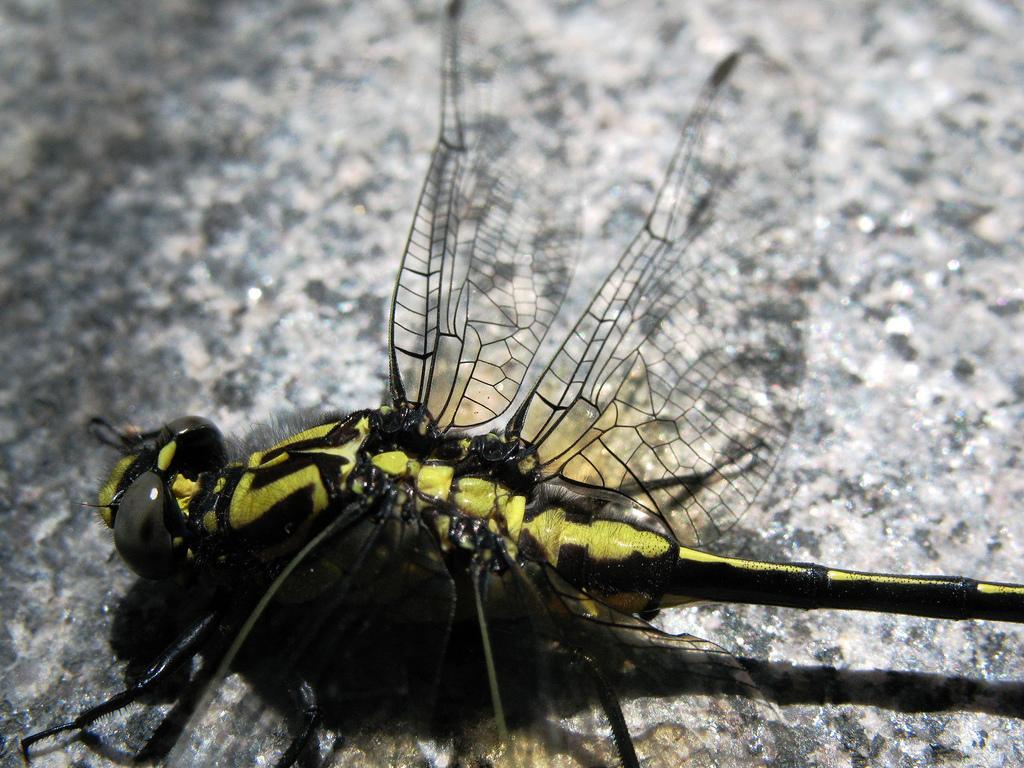Please provide a concise description of this image. In this image we can see an insect on the surface. 